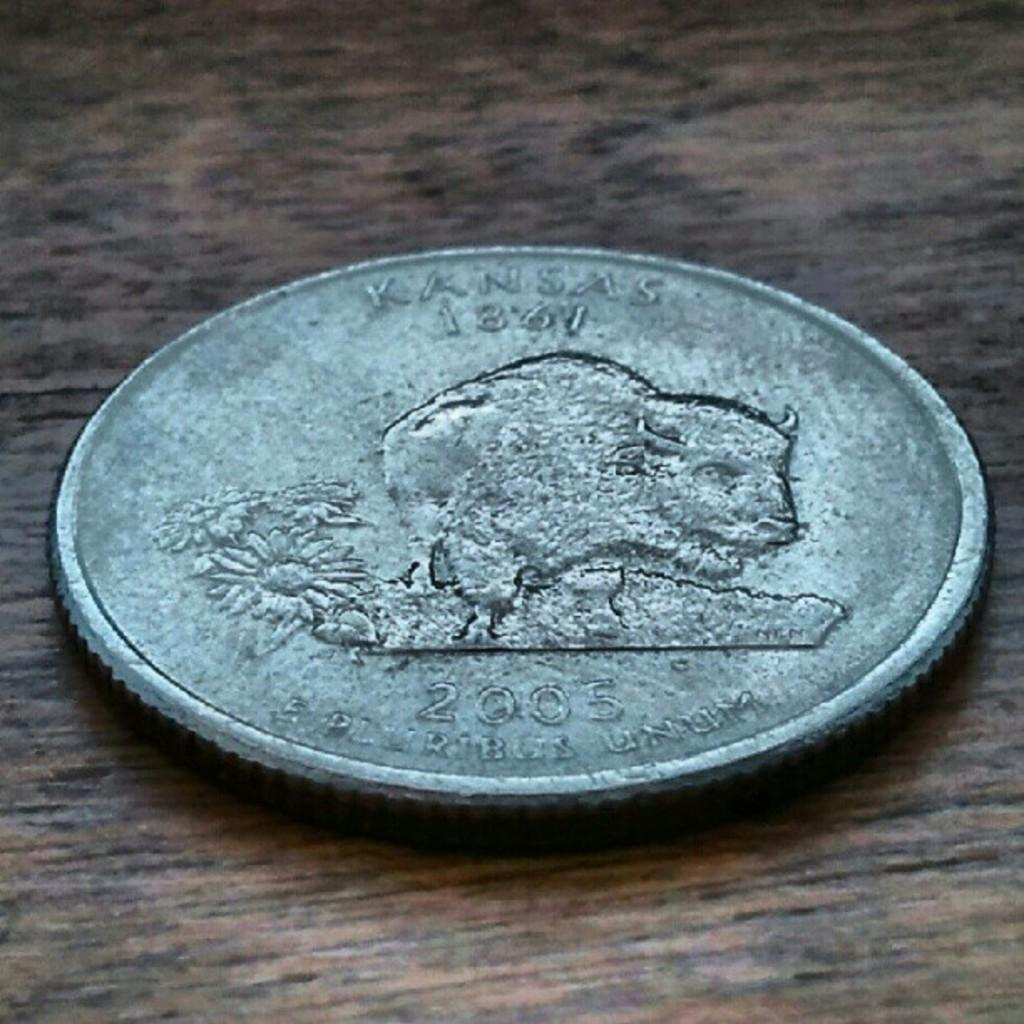What object is present on the wooden surface in the image? There is a coin on the wooden surface in the image. What can be seen on the coin? There is writing and images on the coin, including an animal image and a flower image. What type of stew is being prepared in the image? There is no stew present in the image; it features a coin on a wooden surface. Can you describe the hen in the image? There is no hen present in the image. 